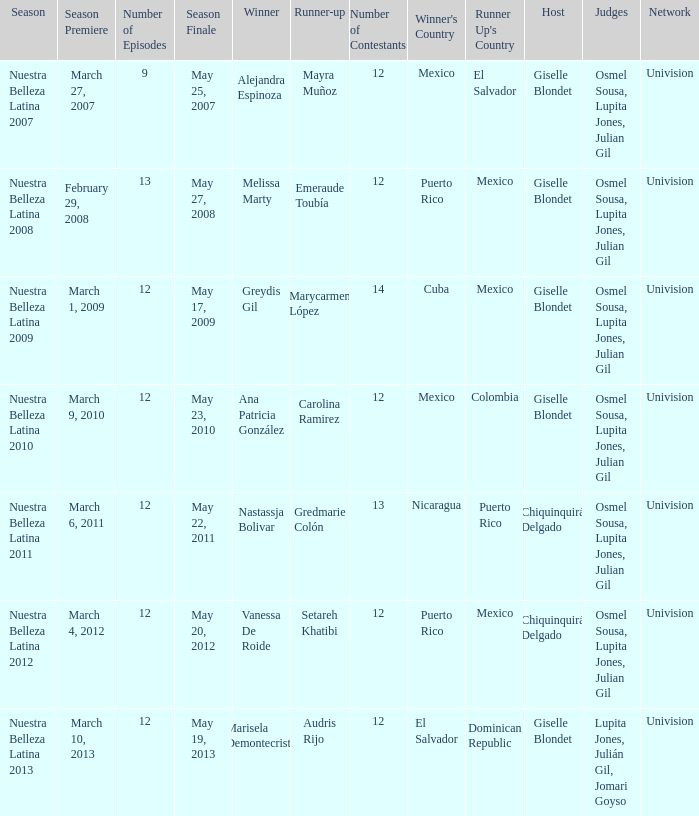How many contestants were there on March 1, 2009 during the season premiere? 14.0. 